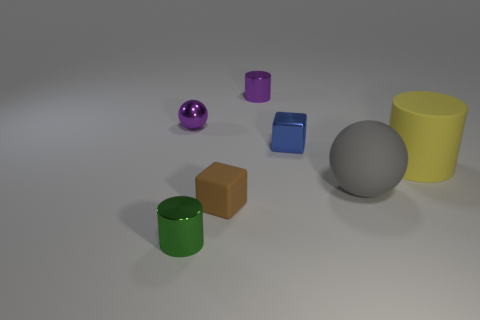What shape is the metallic thing that is behind the tiny purple thing that is to the left of the small purple metallic thing right of the tiny green metal object?
Make the answer very short. Cylinder. Is the number of big yellow objects in front of the tiny green thing greater than the number of yellow matte cylinders?
Your answer should be compact. No. Does the green thing have the same shape as the small thing that is on the right side of the small purple cylinder?
Your answer should be compact. No. What shape is the small metallic object that is the same color as the tiny metal ball?
Offer a terse response. Cylinder. There is a tiny metallic cylinder that is to the left of the purple object that is right of the matte block; what number of small purple metallic cylinders are behind it?
Your response must be concise. 1. What is the color of the rubber cylinder that is the same size as the gray rubber ball?
Offer a terse response. Yellow. There is a rubber thing left of the big object that is left of the matte cylinder; how big is it?
Ensure brevity in your answer.  Small. There is a metal object that is the same color as the metallic sphere; what size is it?
Your response must be concise. Small. What number of other objects are there of the same size as the matte cylinder?
Provide a succinct answer. 1. How many brown matte spheres are there?
Offer a very short reply. 0. 